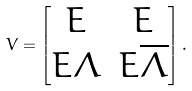Convert formula to latex. <formula><loc_0><loc_0><loc_500><loc_500>V = \begin{bmatrix} E & E \\ E \Lambda & E \overline { \Lambda } \end{bmatrix} .</formula> 